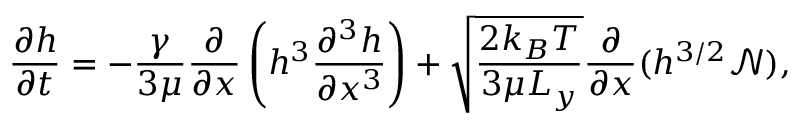Convert formula to latex. <formula><loc_0><loc_0><loc_500><loc_500>\frac { \partial h } { \partial t } = - \frac { \gamma } { 3 \mu } \frac { \partial } { \partial x } \left ( h ^ { 3 } \frac { \partial ^ { 3 } h } { \partial x ^ { 3 } } \right ) + \sqrt { \frac { 2 k _ { B } T } { 3 \mu L _ { y } } } \frac { \partial } { \partial x } ( h ^ { 3 / 2 } \mathcal { N } ) ,</formula> 